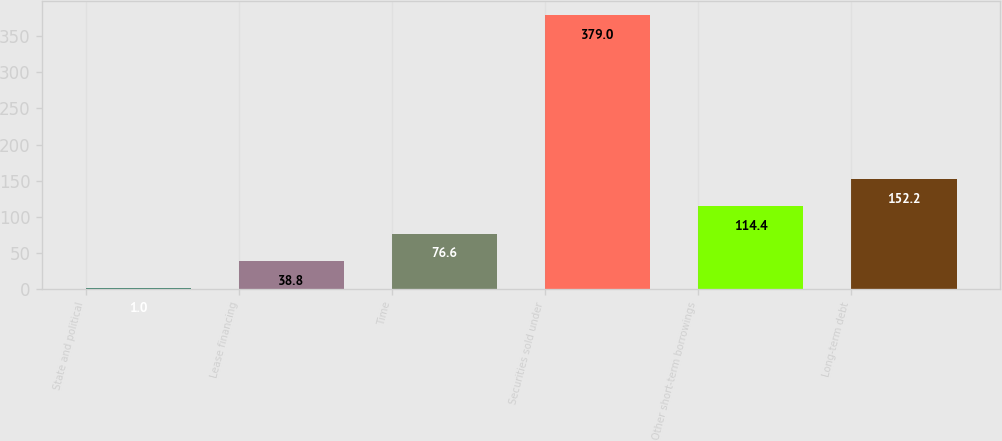Convert chart. <chart><loc_0><loc_0><loc_500><loc_500><bar_chart><fcel>State and political<fcel>Lease financing<fcel>Time<fcel>Securities sold under<fcel>Other short-term borrowings<fcel>Long-term debt<nl><fcel>1<fcel>38.8<fcel>76.6<fcel>379<fcel>114.4<fcel>152.2<nl></chart> 